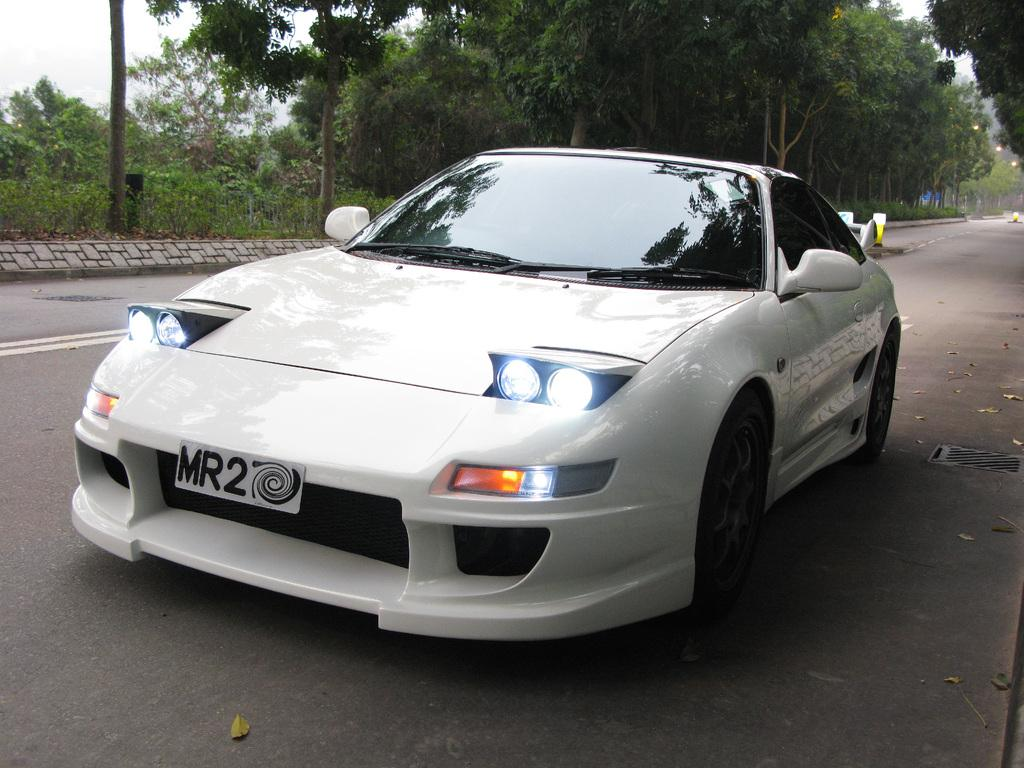What is the main subject of the image? The main subject of the image is a car. Can you describe the color of the car? The car is white. What type of vegetation can be seen in the image? There are trees at the back side of the image. Where are the lights located in the image? The lights are on the right side of the image. What type of voice can be heard coming from the car in the image? There is no voice present in the image, as it is a still photograph of a car. 